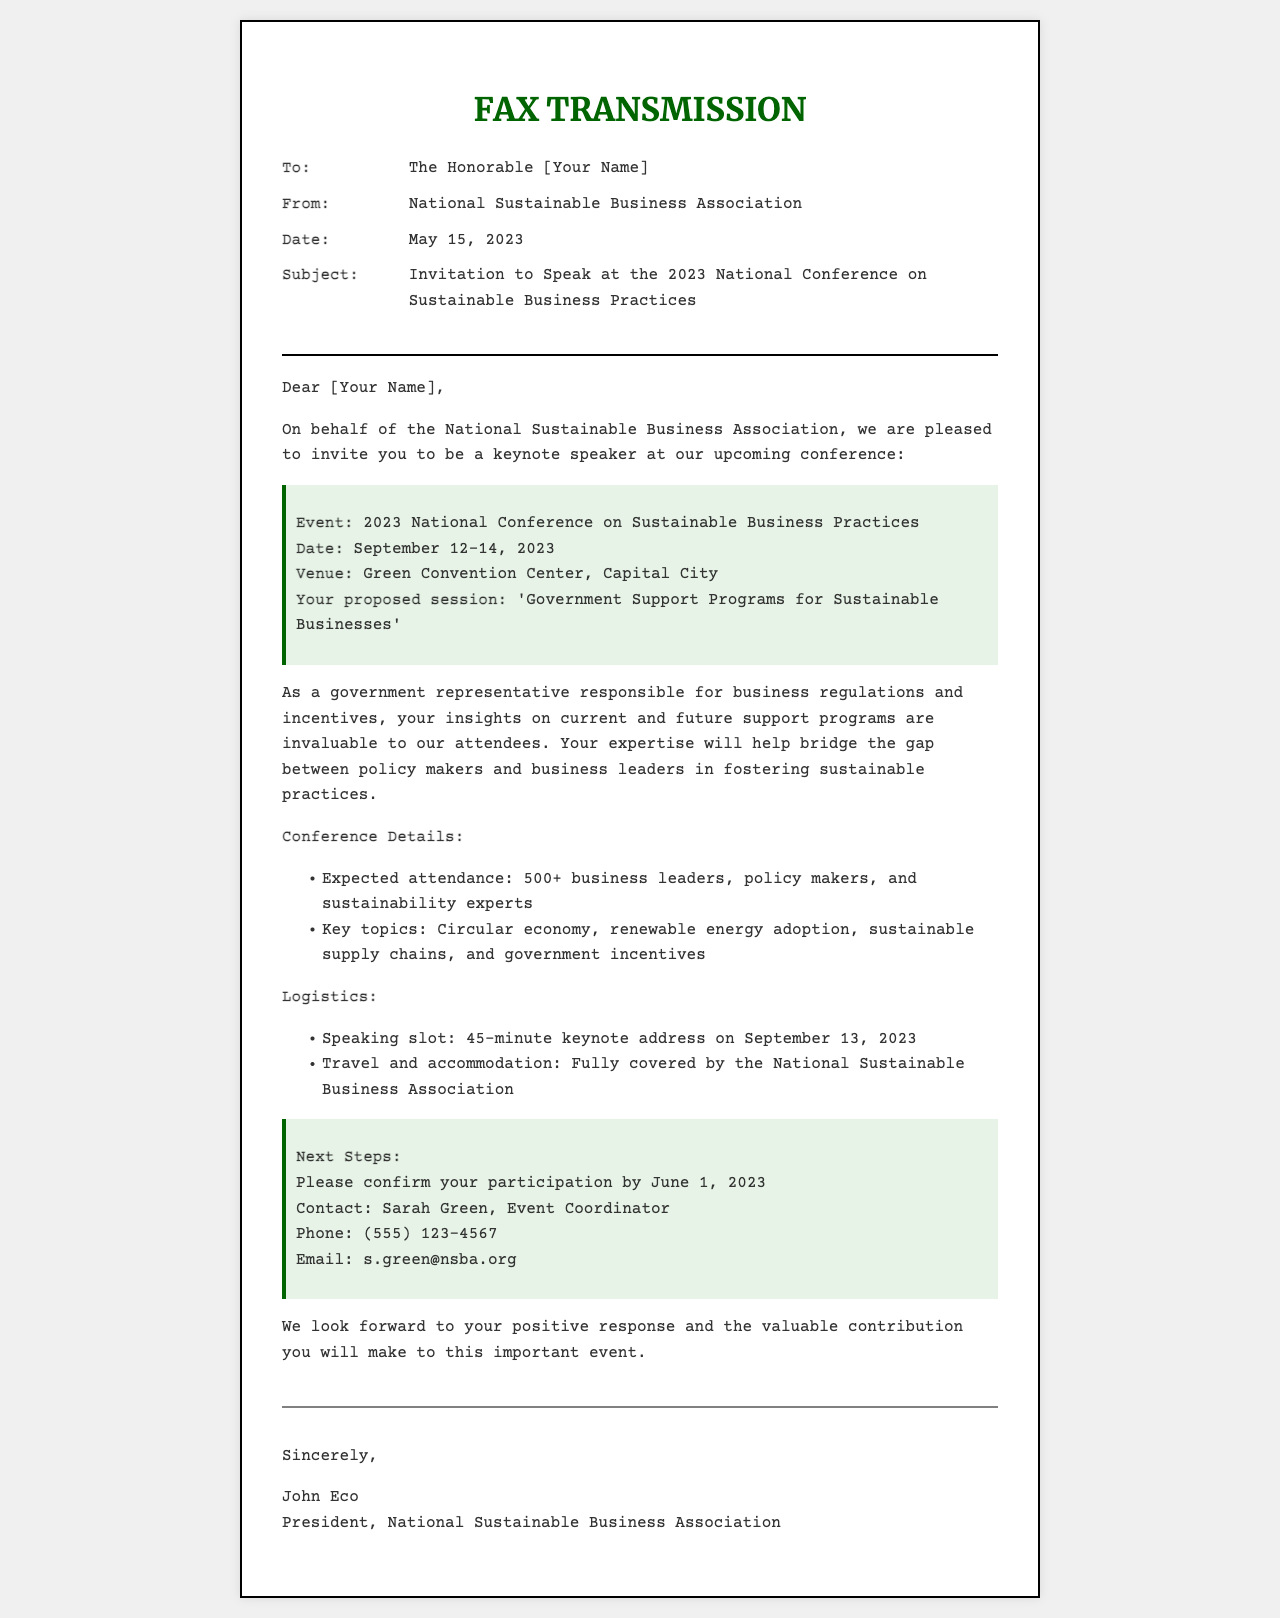What is the date of the conference? The date of the conference is specified in the document as September 12-14, 2023.
Answer: September 12-14, 2023 Who is the sender of the fax? The sender of the fax is identified as the National Sustainable Business Association.
Answer: National Sustainable Business Association What is the proposed session title? The proposed session title is included in the highlight section of the document.
Answer: Government Support Programs for Sustainable Businesses When do they want a confirmation of participation? The document specifies the deadline for confirmation in the highlight section.
Answer: June 1, 2023 What will be covered for travel and accommodation? The logistics section mentions how travel and accommodation expenses will be managed.
Answer: Fully covered by the National Sustainable Business Association What is expected attendance at the conference? The expected attendance is mentioned in the conference details.
Answer: 500+ What is the location of the conference? The venue is stated in the highlight section of the document.
Answer: Green Convention Center, Capital City How long is the keynote address? The duration of the speaking slot is indicated in the logistics section.
Answer: 45-minute Who should be contacted for more information? The contact person for further information is listed in the next steps section.
Answer: Sarah Green 